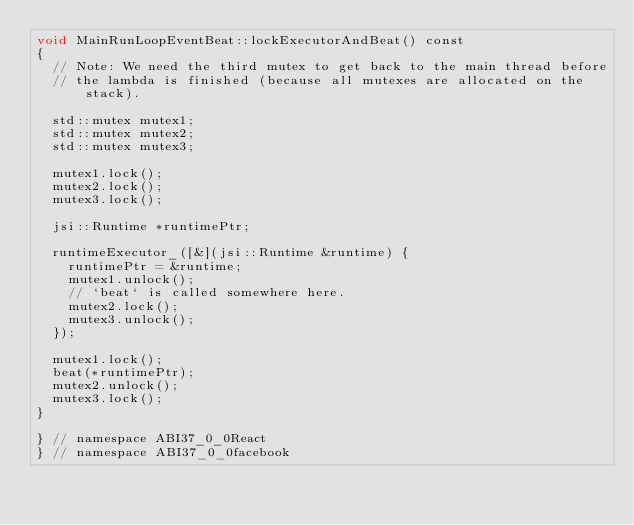<code> <loc_0><loc_0><loc_500><loc_500><_ObjectiveC_>void MainRunLoopEventBeat::lockExecutorAndBeat() const
{
  // Note: We need the third mutex to get back to the main thread before
  // the lambda is finished (because all mutexes are allocated on the stack).

  std::mutex mutex1;
  std::mutex mutex2;
  std::mutex mutex3;

  mutex1.lock();
  mutex2.lock();
  mutex3.lock();

  jsi::Runtime *runtimePtr;

  runtimeExecutor_([&](jsi::Runtime &runtime) {
    runtimePtr = &runtime;
    mutex1.unlock();
    // `beat` is called somewhere here.
    mutex2.lock();
    mutex3.unlock();
  });

  mutex1.lock();
  beat(*runtimePtr);
  mutex2.unlock();
  mutex3.lock();
}

} // namespace ABI37_0_0React
} // namespace ABI37_0_0facebook
</code> 